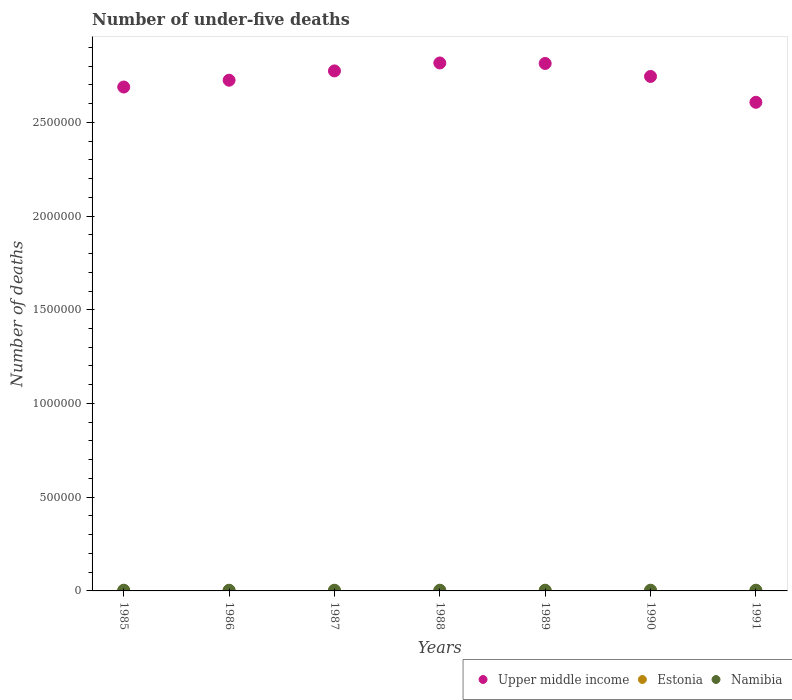How many different coloured dotlines are there?
Provide a short and direct response. 3. Is the number of dotlines equal to the number of legend labels?
Offer a terse response. Yes. What is the number of under-five deaths in Namibia in 1986?
Your response must be concise. 3736. Across all years, what is the maximum number of under-five deaths in Estonia?
Make the answer very short. 567. Across all years, what is the minimum number of under-five deaths in Upper middle income?
Keep it short and to the point. 2.61e+06. In which year was the number of under-five deaths in Namibia minimum?
Offer a terse response. 1986. What is the total number of under-five deaths in Estonia in the graph?
Offer a very short reply. 3698. What is the difference between the number of under-five deaths in Upper middle income in 1985 and that in 1990?
Offer a terse response. -5.64e+04. What is the difference between the number of under-five deaths in Upper middle income in 1989 and the number of under-five deaths in Namibia in 1990?
Your answer should be very brief. 2.81e+06. What is the average number of under-five deaths in Estonia per year?
Make the answer very short. 528.29. In the year 1990, what is the difference between the number of under-five deaths in Namibia and number of under-five deaths in Estonia?
Offer a very short reply. 3285. What is the ratio of the number of under-five deaths in Upper middle income in 1988 to that in 1991?
Your response must be concise. 1.08. What is the difference between the highest and the second highest number of under-five deaths in Upper middle income?
Give a very brief answer. 2616. What is the difference between the highest and the lowest number of under-five deaths in Namibia?
Provide a succinct answer. 58. In how many years, is the number of under-five deaths in Namibia greater than the average number of under-five deaths in Namibia taken over all years?
Your response must be concise. 4. Is the sum of the number of under-five deaths in Namibia in 1985 and 1990 greater than the maximum number of under-five deaths in Estonia across all years?
Your answer should be very brief. Yes. Is it the case that in every year, the sum of the number of under-five deaths in Namibia and number of under-five deaths in Estonia  is greater than the number of under-five deaths in Upper middle income?
Keep it short and to the point. No. How many dotlines are there?
Make the answer very short. 3. How many years are there in the graph?
Your response must be concise. 7. Are the values on the major ticks of Y-axis written in scientific E-notation?
Give a very brief answer. No. How many legend labels are there?
Provide a succinct answer. 3. What is the title of the graph?
Your response must be concise. Number of under-five deaths. What is the label or title of the Y-axis?
Your answer should be very brief. Number of deaths. What is the Number of deaths in Upper middle income in 1985?
Provide a succinct answer. 2.69e+06. What is the Number of deaths in Estonia in 1985?
Provide a short and direct response. 565. What is the Number of deaths in Namibia in 1985?
Your response must be concise. 3789. What is the Number of deaths of Upper middle income in 1986?
Keep it short and to the point. 2.72e+06. What is the Number of deaths in Estonia in 1986?
Offer a terse response. 567. What is the Number of deaths in Namibia in 1986?
Ensure brevity in your answer.  3736. What is the Number of deaths of Upper middle income in 1987?
Your response must be concise. 2.77e+06. What is the Number of deaths in Estonia in 1987?
Give a very brief answer. 563. What is the Number of deaths in Namibia in 1987?
Provide a short and direct response. 3736. What is the Number of deaths of Upper middle income in 1988?
Your response must be concise. 2.82e+06. What is the Number of deaths in Estonia in 1988?
Give a very brief answer. 554. What is the Number of deaths of Namibia in 1988?
Provide a succinct answer. 3752. What is the Number of deaths in Upper middle income in 1989?
Your answer should be compact. 2.81e+06. What is the Number of deaths in Estonia in 1989?
Provide a succinct answer. 529. What is the Number of deaths in Namibia in 1989?
Ensure brevity in your answer.  3766. What is the Number of deaths in Upper middle income in 1990?
Your response must be concise. 2.74e+06. What is the Number of deaths in Estonia in 1990?
Provide a short and direct response. 486. What is the Number of deaths of Namibia in 1990?
Give a very brief answer. 3771. What is the Number of deaths in Upper middle income in 1991?
Your response must be concise. 2.61e+06. What is the Number of deaths of Estonia in 1991?
Keep it short and to the point. 434. What is the Number of deaths of Namibia in 1991?
Ensure brevity in your answer.  3794. Across all years, what is the maximum Number of deaths in Upper middle income?
Ensure brevity in your answer.  2.82e+06. Across all years, what is the maximum Number of deaths in Estonia?
Your response must be concise. 567. Across all years, what is the maximum Number of deaths of Namibia?
Your answer should be compact. 3794. Across all years, what is the minimum Number of deaths of Upper middle income?
Provide a succinct answer. 2.61e+06. Across all years, what is the minimum Number of deaths of Estonia?
Make the answer very short. 434. Across all years, what is the minimum Number of deaths in Namibia?
Provide a short and direct response. 3736. What is the total Number of deaths in Upper middle income in the graph?
Your response must be concise. 1.92e+07. What is the total Number of deaths of Estonia in the graph?
Make the answer very short. 3698. What is the total Number of deaths in Namibia in the graph?
Give a very brief answer. 2.63e+04. What is the difference between the Number of deaths of Upper middle income in 1985 and that in 1986?
Your answer should be compact. -3.64e+04. What is the difference between the Number of deaths of Estonia in 1985 and that in 1986?
Your response must be concise. -2. What is the difference between the Number of deaths in Upper middle income in 1985 and that in 1987?
Your answer should be compact. -8.60e+04. What is the difference between the Number of deaths in Estonia in 1985 and that in 1987?
Ensure brevity in your answer.  2. What is the difference between the Number of deaths in Upper middle income in 1985 and that in 1988?
Give a very brief answer. -1.28e+05. What is the difference between the Number of deaths in Namibia in 1985 and that in 1988?
Ensure brevity in your answer.  37. What is the difference between the Number of deaths of Upper middle income in 1985 and that in 1989?
Your answer should be very brief. -1.26e+05. What is the difference between the Number of deaths of Estonia in 1985 and that in 1989?
Give a very brief answer. 36. What is the difference between the Number of deaths in Upper middle income in 1985 and that in 1990?
Provide a succinct answer. -5.64e+04. What is the difference between the Number of deaths in Estonia in 1985 and that in 1990?
Give a very brief answer. 79. What is the difference between the Number of deaths in Upper middle income in 1985 and that in 1991?
Keep it short and to the point. 8.15e+04. What is the difference between the Number of deaths of Estonia in 1985 and that in 1991?
Your answer should be very brief. 131. What is the difference between the Number of deaths in Namibia in 1985 and that in 1991?
Your response must be concise. -5. What is the difference between the Number of deaths in Upper middle income in 1986 and that in 1987?
Keep it short and to the point. -4.97e+04. What is the difference between the Number of deaths in Estonia in 1986 and that in 1987?
Offer a terse response. 4. What is the difference between the Number of deaths of Namibia in 1986 and that in 1987?
Your response must be concise. 0. What is the difference between the Number of deaths of Upper middle income in 1986 and that in 1988?
Give a very brief answer. -9.20e+04. What is the difference between the Number of deaths of Namibia in 1986 and that in 1988?
Your answer should be compact. -16. What is the difference between the Number of deaths of Upper middle income in 1986 and that in 1989?
Ensure brevity in your answer.  -8.94e+04. What is the difference between the Number of deaths of Estonia in 1986 and that in 1989?
Your answer should be very brief. 38. What is the difference between the Number of deaths of Namibia in 1986 and that in 1989?
Provide a succinct answer. -30. What is the difference between the Number of deaths of Upper middle income in 1986 and that in 1990?
Your answer should be compact. -2.01e+04. What is the difference between the Number of deaths of Estonia in 1986 and that in 1990?
Offer a very short reply. 81. What is the difference between the Number of deaths in Namibia in 1986 and that in 1990?
Give a very brief answer. -35. What is the difference between the Number of deaths in Upper middle income in 1986 and that in 1991?
Your answer should be very brief. 1.18e+05. What is the difference between the Number of deaths in Estonia in 1986 and that in 1991?
Your response must be concise. 133. What is the difference between the Number of deaths in Namibia in 1986 and that in 1991?
Give a very brief answer. -58. What is the difference between the Number of deaths of Upper middle income in 1987 and that in 1988?
Your answer should be very brief. -4.23e+04. What is the difference between the Number of deaths in Namibia in 1987 and that in 1988?
Your answer should be very brief. -16. What is the difference between the Number of deaths in Upper middle income in 1987 and that in 1989?
Keep it short and to the point. -3.97e+04. What is the difference between the Number of deaths of Estonia in 1987 and that in 1989?
Provide a short and direct response. 34. What is the difference between the Number of deaths of Namibia in 1987 and that in 1989?
Provide a short and direct response. -30. What is the difference between the Number of deaths of Upper middle income in 1987 and that in 1990?
Offer a very short reply. 2.96e+04. What is the difference between the Number of deaths in Namibia in 1987 and that in 1990?
Your answer should be compact. -35. What is the difference between the Number of deaths in Upper middle income in 1987 and that in 1991?
Ensure brevity in your answer.  1.68e+05. What is the difference between the Number of deaths in Estonia in 1987 and that in 1991?
Ensure brevity in your answer.  129. What is the difference between the Number of deaths of Namibia in 1987 and that in 1991?
Ensure brevity in your answer.  -58. What is the difference between the Number of deaths of Upper middle income in 1988 and that in 1989?
Offer a very short reply. 2616. What is the difference between the Number of deaths in Namibia in 1988 and that in 1989?
Your answer should be very brief. -14. What is the difference between the Number of deaths in Upper middle income in 1988 and that in 1990?
Give a very brief answer. 7.19e+04. What is the difference between the Number of deaths of Upper middle income in 1988 and that in 1991?
Provide a short and direct response. 2.10e+05. What is the difference between the Number of deaths of Estonia in 1988 and that in 1991?
Ensure brevity in your answer.  120. What is the difference between the Number of deaths in Namibia in 1988 and that in 1991?
Provide a succinct answer. -42. What is the difference between the Number of deaths of Upper middle income in 1989 and that in 1990?
Your answer should be compact. 6.93e+04. What is the difference between the Number of deaths in Estonia in 1989 and that in 1990?
Provide a short and direct response. 43. What is the difference between the Number of deaths in Upper middle income in 1989 and that in 1991?
Offer a terse response. 2.07e+05. What is the difference between the Number of deaths of Estonia in 1989 and that in 1991?
Give a very brief answer. 95. What is the difference between the Number of deaths in Namibia in 1989 and that in 1991?
Offer a very short reply. -28. What is the difference between the Number of deaths in Upper middle income in 1990 and that in 1991?
Make the answer very short. 1.38e+05. What is the difference between the Number of deaths of Namibia in 1990 and that in 1991?
Make the answer very short. -23. What is the difference between the Number of deaths of Upper middle income in 1985 and the Number of deaths of Estonia in 1986?
Provide a succinct answer. 2.69e+06. What is the difference between the Number of deaths of Upper middle income in 1985 and the Number of deaths of Namibia in 1986?
Ensure brevity in your answer.  2.68e+06. What is the difference between the Number of deaths of Estonia in 1985 and the Number of deaths of Namibia in 1986?
Provide a succinct answer. -3171. What is the difference between the Number of deaths of Upper middle income in 1985 and the Number of deaths of Estonia in 1987?
Your answer should be compact. 2.69e+06. What is the difference between the Number of deaths in Upper middle income in 1985 and the Number of deaths in Namibia in 1987?
Your answer should be compact. 2.68e+06. What is the difference between the Number of deaths in Estonia in 1985 and the Number of deaths in Namibia in 1987?
Offer a very short reply. -3171. What is the difference between the Number of deaths in Upper middle income in 1985 and the Number of deaths in Estonia in 1988?
Ensure brevity in your answer.  2.69e+06. What is the difference between the Number of deaths of Upper middle income in 1985 and the Number of deaths of Namibia in 1988?
Make the answer very short. 2.68e+06. What is the difference between the Number of deaths of Estonia in 1985 and the Number of deaths of Namibia in 1988?
Your response must be concise. -3187. What is the difference between the Number of deaths of Upper middle income in 1985 and the Number of deaths of Estonia in 1989?
Offer a very short reply. 2.69e+06. What is the difference between the Number of deaths in Upper middle income in 1985 and the Number of deaths in Namibia in 1989?
Your answer should be compact. 2.68e+06. What is the difference between the Number of deaths of Estonia in 1985 and the Number of deaths of Namibia in 1989?
Provide a succinct answer. -3201. What is the difference between the Number of deaths of Upper middle income in 1985 and the Number of deaths of Estonia in 1990?
Offer a terse response. 2.69e+06. What is the difference between the Number of deaths in Upper middle income in 1985 and the Number of deaths in Namibia in 1990?
Make the answer very short. 2.68e+06. What is the difference between the Number of deaths in Estonia in 1985 and the Number of deaths in Namibia in 1990?
Make the answer very short. -3206. What is the difference between the Number of deaths in Upper middle income in 1985 and the Number of deaths in Estonia in 1991?
Your answer should be very brief. 2.69e+06. What is the difference between the Number of deaths of Upper middle income in 1985 and the Number of deaths of Namibia in 1991?
Provide a succinct answer. 2.68e+06. What is the difference between the Number of deaths in Estonia in 1985 and the Number of deaths in Namibia in 1991?
Ensure brevity in your answer.  -3229. What is the difference between the Number of deaths in Upper middle income in 1986 and the Number of deaths in Estonia in 1987?
Your answer should be compact. 2.72e+06. What is the difference between the Number of deaths of Upper middle income in 1986 and the Number of deaths of Namibia in 1987?
Offer a very short reply. 2.72e+06. What is the difference between the Number of deaths in Estonia in 1986 and the Number of deaths in Namibia in 1987?
Give a very brief answer. -3169. What is the difference between the Number of deaths of Upper middle income in 1986 and the Number of deaths of Estonia in 1988?
Provide a short and direct response. 2.72e+06. What is the difference between the Number of deaths of Upper middle income in 1986 and the Number of deaths of Namibia in 1988?
Make the answer very short. 2.72e+06. What is the difference between the Number of deaths in Estonia in 1986 and the Number of deaths in Namibia in 1988?
Make the answer very short. -3185. What is the difference between the Number of deaths of Upper middle income in 1986 and the Number of deaths of Estonia in 1989?
Your response must be concise. 2.72e+06. What is the difference between the Number of deaths of Upper middle income in 1986 and the Number of deaths of Namibia in 1989?
Give a very brief answer. 2.72e+06. What is the difference between the Number of deaths in Estonia in 1986 and the Number of deaths in Namibia in 1989?
Keep it short and to the point. -3199. What is the difference between the Number of deaths in Upper middle income in 1986 and the Number of deaths in Estonia in 1990?
Your response must be concise. 2.72e+06. What is the difference between the Number of deaths of Upper middle income in 1986 and the Number of deaths of Namibia in 1990?
Give a very brief answer. 2.72e+06. What is the difference between the Number of deaths of Estonia in 1986 and the Number of deaths of Namibia in 1990?
Provide a succinct answer. -3204. What is the difference between the Number of deaths in Upper middle income in 1986 and the Number of deaths in Estonia in 1991?
Provide a succinct answer. 2.72e+06. What is the difference between the Number of deaths of Upper middle income in 1986 and the Number of deaths of Namibia in 1991?
Make the answer very short. 2.72e+06. What is the difference between the Number of deaths of Estonia in 1986 and the Number of deaths of Namibia in 1991?
Provide a succinct answer. -3227. What is the difference between the Number of deaths of Upper middle income in 1987 and the Number of deaths of Estonia in 1988?
Make the answer very short. 2.77e+06. What is the difference between the Number of deaths of Upper middle income in 1987 and the Number of deaths of Namibia in 1988?
Make the answer very short. 2.77e+06. What is the difference between the Number of deaths in Estonia in 1987 and the Number of deaths in Namibia in 1988?
Your answer should be very brief. -3189. What is the difference between the Number of deaths in Upper middle income in 1987 and the Number of deaths in Estonia in 1989?
Offer a very short reply. 2.77e+06. What is the difference between the Number of deaths of Upper middle income in 1987 and the Number of deaths of Namibia in 1989?
Provide a succinct answer. 2.77e+06. What is the difference between the Number of deaths of Estonia in 1987 and the Number of deaths of Namibia in 1989?
Offer a very short reply. -3203. What is the difference between the Number of deaths of Upper middle income in 1987 and the Number of deaths of Estonia in 1990?
Give a very brief answer. 2.77e+06. What is the difference between the Number of deaths of Upper middle income in 1987 and the Number of deaths of Namibia in 1990?
Give a very brief answer. 2.77e+06. What is the difference between the Number of deaths in Estonia in 1987 and the Number of deaths in Namibia in 1990?
Provide a succinct answer. -3208. What is the difference between the Number of deaths in Upper middle income in 1987 and the Number of deaths in Estonia in 1991?
Keep it short and to the point. 2.77e+06. What is the difference between the Number of deaths in Upper middle income in 1987 and the Number of deaths in Namibia in 1991?
Keep it short and to the point. 2.77e+06. What is the difference between the Number of deaths of Estonia in 1987 and the Number of deaths of Namibia in 1991?
Provide a succinct answer. -3231. What is the difference between the Number of deaths in Upper middle income in 1988 and the Number of deaths in Estonia in 1989?
Provide a short and direct response. 2.82e+06. What is the difference between the Number of deaths of Upper middle income in 1988 and the Number of deaths of Namibia in 1989?
Offer a terse response. 2.81e+06. What is the difference between the Number of deaths of Estonia in 1988 and the Number of deaths of Namibia in 1989?
Provide a short and direct response. -3212. What is the difference between the Number of deaths of Upper middle income in 1988 and the Number of deaths of Estonia in 1990?
Provide a short and direct response. 2.82e+06. What is the difference between the Number of deaths of Upper middle income in 1988 and the Number of deaths of Namibia in 1990?
Provide a succinct answer. 2.81e+06. What is the difference between the Number of deaths of Estonia in 1988 and the Number of deaths of Namibia in 1990?
Ensure brevity in your answer.  -3217. What is the difference between the Number of deaths in Upper middle income in 1988 and the Number of deaths in Estonia in 1991?
Provide a succinct answer. 2.82e+06. What is the difference between the Number of deaths of Upper middle income in 1988 and the Number of deaths of Namibia in 1991?
Offer a terse response. 2.81e+06. What is the difference between the Number of deaths in Estonia in 1988 and the Number of deaths in Namibia in 1991?
Offer a very short reply. -3240. What is the difference between the Number of deaths of Upper middle income in 1989 and the Number of deaths of Estonia in 1990?
Offer a very short reply. 2.81e+06. What is the difference between the Number of deaths of Upper middle income in 1989 and the Number of deaths of Namibia in 1990?
Offer a very short reply. 2.81e+06. What is the difference between the Number of deaths of Estonia in 1989 and the Number of deaths of Namibia in 1990?
Offer a very short reply. -3242. What is the difference between the Number of deaths of Upper middle income in 1989 and the Number of deaths of Estonia in 1991?
Offer a very short reply. 2.81e+06. What is the difference between the Number of deaths of Upper middle income in 1989 and the Number of deaths of Namibia in 1991?
Make the answer very short. 2.81e+06. What is the difference between the Number of deaths of Estonia in 1989 and the Number of deaths of Namibia in 1991?
Keep it short and to the point. -3265. What is the difference between the Number of deaths in Upper middle income in 1990 and the Number of deaths in Estonia in 1991?
Make the answer very short. 2.74e+06. What is the difference between the Number of deaths in Upper middle income in 1990 and the Number of deaths in Namibia in 1991?
Offer a very short reply. 2.74e+06. What is the difference between the Number of deaths in Estonia in 1990 and the Number of deaths in Namibia in 1991?
Offer a terse response. -3308. What is the average Number of deaths of Upper middle income per year?
Your answer should be compact. 2.74e+06. What is the average Number of deaths in Estonia per year?
Make the answer very short. 528.29. What is the average Number of deaths in Namibia per year?
Your response must be concise. 3763.43. In the year 1985, what is the difference between the Number of deaths in Upper middle income and Number of deaths in Estonia?
Give a very brief answer. 2.69e+06. In the year 1985, what is the difference between the Number of deaths of Upper middle income and Number of deaths of Namibia?
Offer a terse response. 2.68e+06. In the year 1985, what is the difference between the Number of deaths of Estonia and Number of deaths of Namibia?
Provide a short and direct response. -3224. In the year 1986, what is the difference between the Number of deaths of Upper middle income and Number of deaths of Estonia?
Offer a terse response. 2.72e+06. In the year 1986, what is the difference between the Number of deaths of Upper middle income and Number of deaths of Namibia?
Give a very brief answer. 2.72e+06. In the year 1986, what is the difference between the Number of deaths in Estonia and Number of deaths in Namibia?
Provide a short and direct response. -3169. In the year 1987, what is the difference between the Number of deaths of Upper middle income and Number of deaths of Estonia?
Provide a short and direct response. 2.77e+06. In the year 1987, what is the difference between the Number of deaths of Upper middle income and Number of deaths of Namibia?
Keep it short and to the point. 2.77e+06. In the year 1987, what is the difference between the Number of deaths of Estonia and Number of deaths of Namibia?
Offer a terse response. -3173. In the year 1988, what is the difference between the Number of deaths in Upper middle income and Number of deaths in Estonia?
Ensure brevity in your answer.  2.82e+06. In the year 1988, what is the difference between the Number of deaths of Upper middle income and Number of deaths of Namibia?
Ensure brevity in your answer.  2.81e+06. In the year 1988, what is the difference between the Number of deaths in Estonia and Number of deaths in Namibia?
Offer a very short reply. -3198. In the year 1989, what is the difference between the Number of deaths in Upper middle income and Number of deaths in Estonia?
Your answer should be very brief. 2.81e+06. In the year 1989, what is the difference between the Number of deaths of Upper middle income and Number of deaths of Namibia?
Provide a succinct answer. 2.81e+06. In the year 1989, what is the difference between the Number of deaths of Estonia and Number of deaths of Namibia?
Provide a short and direct response. -3237. In the year 1990, what is the difference between the Number of deaths in Upper middle income and Number of deaths in Estonia?
Your response must be concise. 2.74e+06. In the year 1990, what is the difference between the Number of deaths of Upper middle income and Number of deaths of Namibia?
Your answer should be very brief. 2.74e+06. In the year 1990, what is the difference between the Number of deaths of Estonia and Number of deaths of Namibia?
Make the answer very short. -3285. In the year 1991, what is the difference between the Number of deaths in Upper middle income and Number of deaths in Estonia?
Your response must be concise. 2.61e+06. In the year 1991, what is the difference between the Number of deaths in Upper middle income and Number of deaths in Namibia?
Provide a succinct answer. 2.60e+06. In the year 1991, what is the difference between the Number of deaths of Estonia and Number of deaths of Namibia?
Your answer should be very brief. -3360. What is the ratio of the Number of deaths of Upper middle income in 1985 to that in 1986?
Your answer should be compact. 0.99. What is the ratio of the Number of deaths in Estonia in 1985 to that in 1986?
Make the answer very short. 1. What is the ratio of the Number of deaths in Namibia in 1985 to that in 1986?
Provide a short and direct response. 1.01. What is the ratio of the Number of deaths of Upper middle income in 1985 to that in 1987?
Make the answer very short. 0.97. What is the ratio of the Number of deaths of Namibia in 1985 to that in 1987?
Your response must be concise. 1.01. What is the ratio of the Number of deaths in Upper middle income in 1985 to that in 1988?
Your response must be concise. 0.95. What is the ratio of the Number of deaths of Estonia in 1985 to that in 1988?
Give a very brief answer. 1.02. What is the ratio of the Number of deaths in Namibia in 1985 to that in 1988?
Offer a very short reply. 1.01. What is the ratio of the Number of deaths of Upper middle income in 1985 to that in 1989?
Offer a very short reply. 0.96. What is the ratio of the Number of deaths in Estonia in 1985 to that in 1989?
Your answer should be compact. 1.07. What is the ratio of the Number of deaths in Namibia in 1985 to that in 1989?
Your answer should be compact. 1.01. What is the ratio of the Number of deaths of Upper middle income in 1985 to that in 1990?
Keep it short and to the point. 0.98. What is the ratio of the Number of deaths in Estonia in 1985 to that in 1990?
Provide a succinct answer. 1.16. What is the ratio of the Number of deaths in Upper middle income in 1985 to that in 1991?
Give a very brief answer. 1.03. What is the ratio of the Number of deaths of Estonia in 1985 to that in 1991?
Ensure brevity in your answer.  1.3. What is the ratio of the Number of deaths of Upper middle income in 1986 to that in 1987?
Offer a very short reply. 0.98. What is the ratio of the Number of deaths in Estonia in 1986 to that in 1987?
Make the answer very short. 1.01. What is the ratio of the Number of deaths in Upper middle income in 1986 to that in 1988?
Your response must be concise. 0.97. What is the ratio of the Number of deaths of Estonia in 1986 to that in 1988?
Provide a succinct answer. 1.02. What is the ratio of the Number of deaths of Namibia in 1986 to that in 1988?
Your response must be concise. 1. What is the ratio of the Number of deaths of Upper middle income in 1986 to that in 1989?
Provide a succinct answer. 0.97. What is the ratio of the Number of deaths in Estonia in 1986 to that in 1989?
Provide a succinct answer. 1.07. What is the ratio of the Number of deaths of Namibia in 1986 to that in 1989?
Your answer should be very brief. 0.99. What is the ratio of the Number of deaths in Estonia in 1986 to that in 1990?
Provide a succinct answer. 1.17. What is the ratio of the Number of deaths of Upper middle income in 1986 to that in 1991?
Provide a succinct answer. 1.05. What is the ratio of the Number of deaths in Estonia in 1986 to that in 1991?
Provide a succinct answer. 1.31. What is the ratio of the Number of deaths of Namibia in 1986 to that in 1991?
Your response must be concise. 0.98. What is the ratio of the Number of deaths in Upper middle income in 1987 to that in 1988?
Ensure brevity in your answer.  0.98. What is the ratio of the Number of deaths of Estonia in 1987 to that in 1988?
Your answer should be compact. 1.02. What is the ratio of the Number of deaths in Upper middle income in 1987 to that in 1989?
Offer a terse response. 0.99. What is the ratio of the Number of deaths in Estonia in 1987 to that in 1989?
Your answer should be compact. 1.06. What is the ratio of the Number of deaths in Upper middle income in 1987 to that in 1990?
Keep it short and to the point. 1.01. What is the ratio of the Number of deaths in Estonia in 1987 to that in 1990?
Keep it short and to the point. 1.16. What is the ratio of the Number of deaths in Namibia in 1987 to that in 1990?
Provide a short and direct response. 0.99. What is the ratio of the Number of deaths of Upper middle income in 1987 to that in 1991?
Provide a succinct answer. 1.06. What is the ratio of the Number of deaths of Estonia in 1987 to that in 1991?
Your answer should be compact. 1.3. What is the ratio of the Number of deaths of Namibia in 1987 to that in 1991?
Ensure brevity in your answer.  0.98. What is the ratio of the Number of deaths of Estonia in 1988 to that in 1989?
Ensure brevity in your answer.  1.05. What is the ratio of the Number of deaths in Upper middle income in 1988 to that in 1990?
Offer a terse response. 1.03. What is the ratio of the Number of deaths in Estonia in 1988 to that in 1990?
Your answer should be compact. 1.14. What is the ratio of the Number of deaths in Namibia in 1988 to that in 1990?
Keep it short and to the point. 0.99. What is the ratio of the Number of deaths of Upper middle income in 1988 to that in 1991?
Provide a short and direct response. 1.08. What is the ratio of the Number of deaths in Estonia in 1988 to that in 1991?
Keep it short and to the point. 1.28. What is the ratio of the Number of deaths of Namibia in 1988 to that in 1991?
Keep it short and to the point. 0.99. What is the ratio of the Number of deaths of Upper middle income in 1989 to that in 1990?
Your response must be concise. 1.03. What is the ratio of the Number of deaths of Estonia in 1989 to that in 1990?
Provide a succinct answer. 1.09. What is the ratio of the Number of deaths of Upper middle income in 1989 to that in 1991?
Your answer should be very brief. 1.08. What is the ratio of the Number of deaths of Estonia in 1989 to that in 1991?
Your answer should be compact. 1.22. What is the ratio of the Number of deaths in Namibia in 1989 to that in 1991?
Ensure brevity in your answer.  0.99. What is the ratio of the Number of deaths in Upper middle income in 1990 to that in 1991?
Provide a succinct answer. 1.05. What is the ratio of the Number of deaths of Estonia in 1990 to that in 1991?
Offer a terse response. 1.12. What is the difference between the highest and the second highest Number of deaths of Upper middle income?
Provide a short and direct response. 2616. What is the difference between the highest and the second highest Number of deaths of Estonia?
Your answer should be very brief. 2. What is the difference between the highest and the lowest Number of deaths in Upper middle income?
Provide a succinct answer. 2.10e+05. What is the difference between the highest and the lowest Number of deaths of Estonia?
Your answer should be compact. 133. 